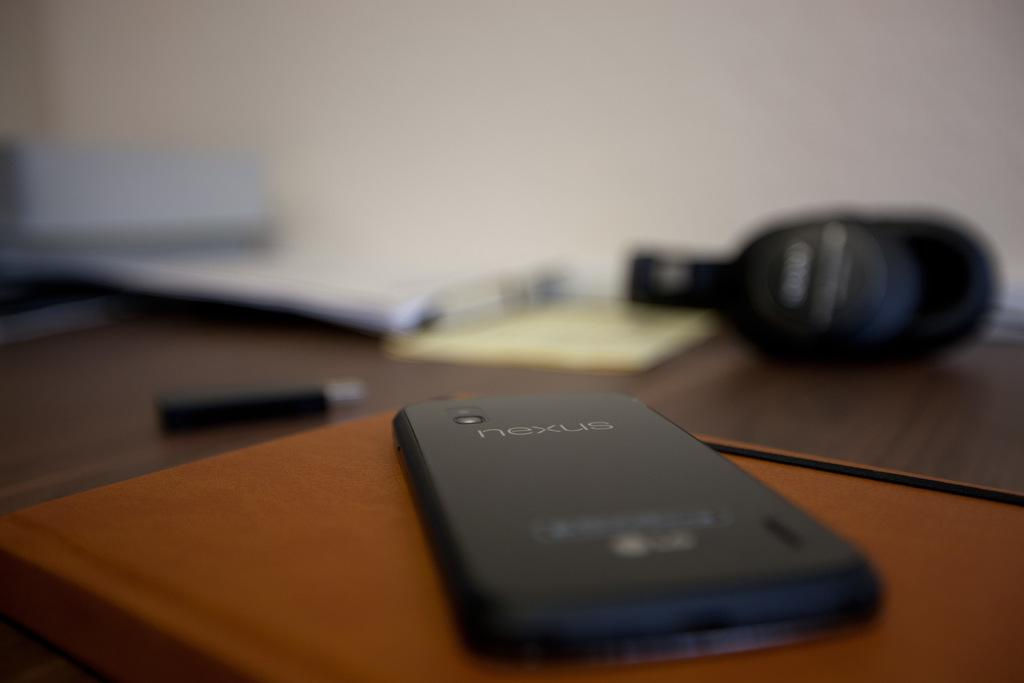<image>
Write a terse but informative summary of the picture. A nexus phone laying on a brown book 